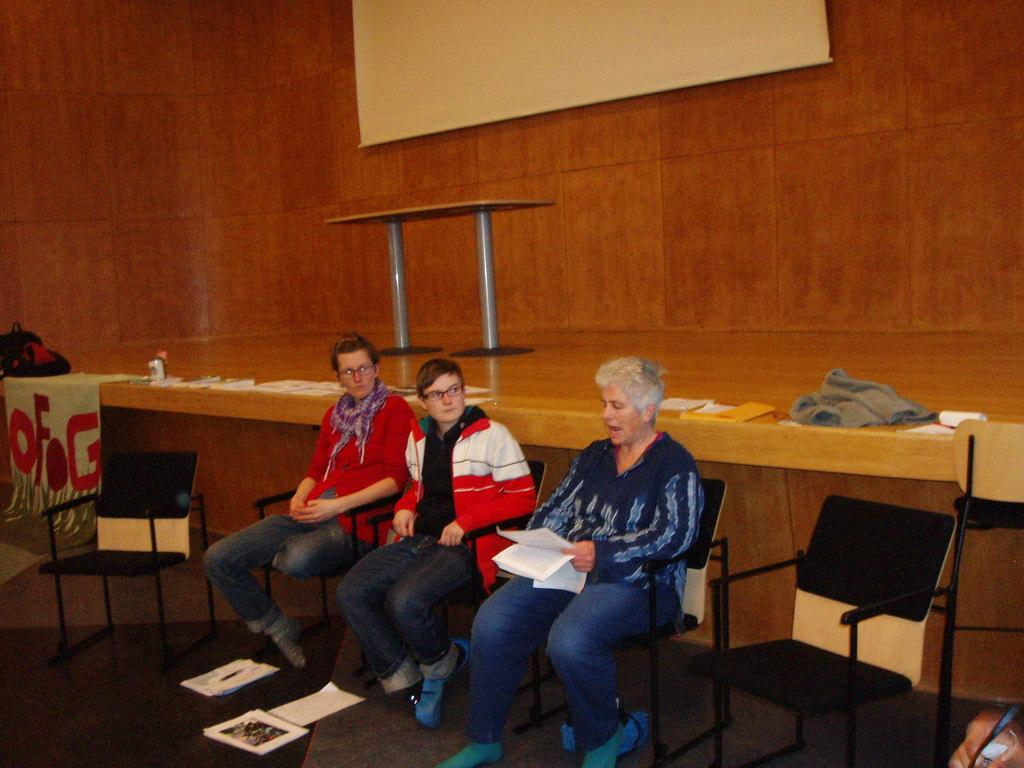How many people are present in the image? There are three people in the image. What are the people sitting on? The people are sitting on black chairs. What color is the wall in the background? The wall in the background is brown. What is attached to the wall? There is an LCD screen attached to the wall. What type of animal can be seen in the image? There is no animal present in the image. Is there a tub visible in the image? No, there is no tub present in the image. 